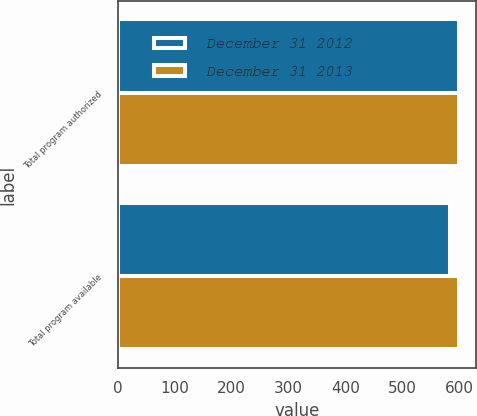Convert chart. <chart><loc_0><loc_0><loc_500><loc_500><stacked_bar_chart><ecel><fcel>Total program authorized<fcel>Total program available<nl><fcel>December 31 2012<fcel>600<fcel>584<nl><fcel>December 31 2013<fcel>600<fcel>600<nl></chart> 